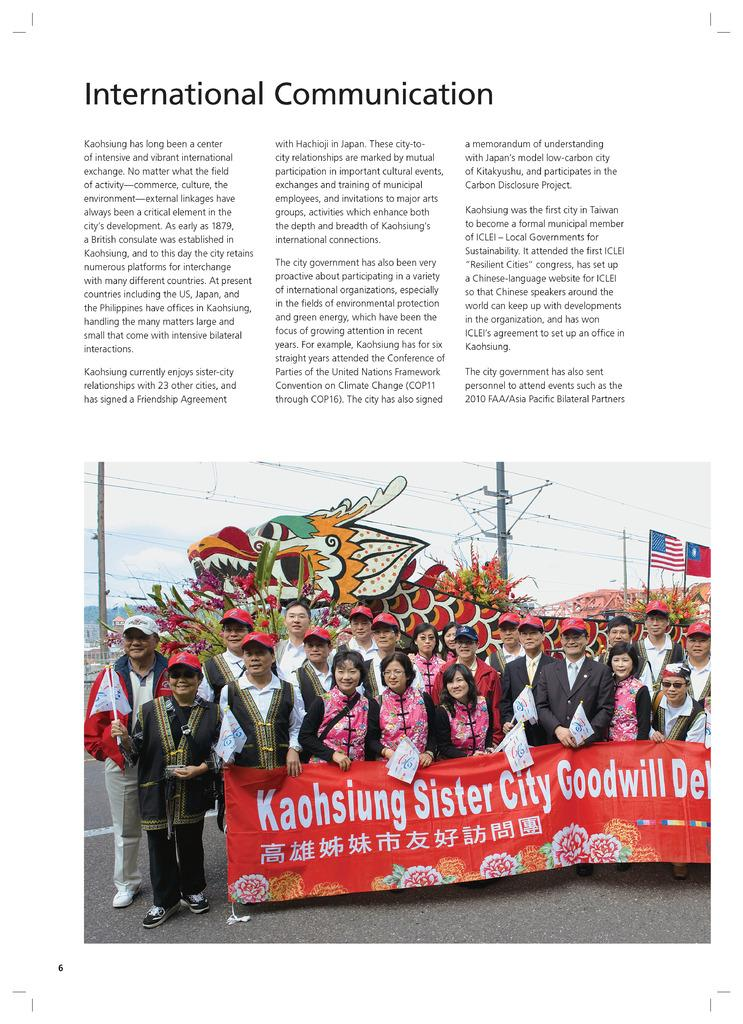What can be found in the image besides the picture? There is some text in the image. What is depicted in the picture? In the picture, there are people, a banner, poles, a flag, wires, and the sky. Can you describe the elements in the picture? In the picture, there are people, a banner, poles, a flag, wires, and the sky. What type of plastic material is used to make the wilderness in the image? There is no wilderness present in the image; it contains a picture with various elements, including people, a banner, poles, a flag, wires, and the sky. 